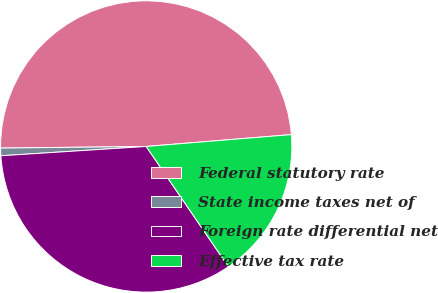Convert chart. <chart><loc_0><loc_0><loc_500><loc_500><pie_chart><fcel>Federal statutory rate<fcel>State income taxes net of<fcel>Foreign rate differential net<fcel>Effective tax rate<nl><fcel>48.88%<fcel>0.84%<fcel>33.52%<fcel>16.76%<nl></chart> 